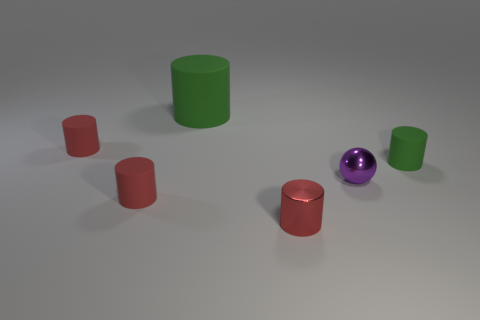There is a metallic object behind the metallic cylinder; is its size the same as the large rubber cylinder?
Give a very brief answer. No. What number of objects are red cylinders that are behind the tiny metallic cylinder or tiny green matte cylinders?
Make the answer very short. 3. Is there a matte object that has the same size as the red metal object?
Provide a succinct answer. Yes. There is a green cylinder that is the same size as the red metallic cylinder; what material is it?
Offer a very short reply. Rubber. What shape is the small thing that is both on the left side of the small green cylinder and behind the ball?
Provide a short and direct response. Cylinder. There is a small matte thing that is on the right side of the small red metal thing; what color is it?
Make the answer very short. Green. How big is the cylinder that is in front of the tiny green thing and right of the large cylinder?
Offer a terse response. Small. Is the material of the large thing the same as the green thing in front of the big green matte thing?
Give a very brief answer. Yes. How many red things are the same shape as the small green object?
Offer a terse response. 3. There is a tiny thing that is the same color as the big rubber cylinder; what is it made of?
Ensure brevity in your answer.  Rubber. 